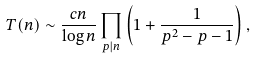Convert formula to latex. <formula><loc_0><loc_0><loc_500><loc_500>T ( n ) \sim \frac { c n } { \log n } \prod _ { p | n } \left ( 1 + \frac { 1 } { p ^ { 2 } - p - 1 } \right ) ,</formula> 